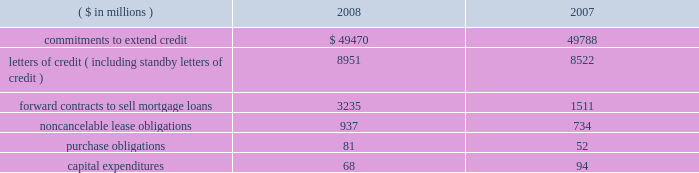Notes to consolidated financial statements fifth third bancorp 81 vii held by the trust vii bear a fixed rate of interest of 8.875% ( 8.875 % ) until may 15 , 2058 .
Thereafter , the notes pay a floating rate at three-month libor plus 500 bp .
The bancorp entered into an interest rate swap to convert $ 275 million of the fixed-rate debt into floating .
At december 31 , 2008 , the rate paid on the swap was 6.05% ( 6.05 % ) .
The jsn vii may be redeemed at the option of the bancorp on or after may 15 , 2013 , or in certain other limited circumstances , at a redemption price of 100% ( 100 % ) of the principal amount plus accrued but unpaid interest .
All redemptions are subject to certain conditions and generally require approval by the federal reserve board .
Subsidiary long-term borrowings the senior fixed-rate bank notes due from 2009 to 2019 are the obligations of a subsidiary bank .
The maturities of the face value of the senior fixed-rate bank notes are as follows : $ 36 million in 2009 , $ 800 million in 2010 and $ 275 million in 2019 .
The bancorp entered into interest rate swaps to convert $ 1.1 billion of the fixed-rate debt into floating rates .
At december 31 , 2008 , the rates paid on these swaps were 2.19% ( 2.19 % ) on $ 800 million and 2.20% ( 2.20 % ) on $ 275 million .
In august 2008 , $ 500 million of senior fixed-rate bank notes issued in july of 2003 matured and were paid .
These long-term bank notes were issued to third-party investors at a fixed rate of 3.375% ( 3.375 % ) .
The senior floating-rate bank notes due in 2013 are the obligations of a subsidiary bank .
The notes pay a floating rate at three-month libor plus 11 bp .
The senior extendable notes consist of $ 797 million that currently pay interest at three-month libor plus 4 bp and $ 400 million that pay at the federal funds open rate plus 12 bp .
The subordinated fixed-rate bank notes due in 2015 are the obligations of a subsidiary bank .
The bancorp entered into interest rate swaps to convert the fixed-rate debt into floating rate .
At december 31 , 2008 , the weighted-average rate paid on the swaps was 3.29% ( 3.29 % ) .
The junior subordinated floating-rate bank notes due in 2032 and 2033 were assumed by a bancorp subsidiary as part of the acquisition of crown in november 2007 .
Two of the notes pay floating at three-month libor plus 310 and 325 bp .
The third note pays floating at six-month libor plus 370 bp .
The three-month libor plus 290 bp and the three-month libor plus 279 bp junior subordinated debentures due in 2033 and 2034 , respectively , were assumed by a subsidiary of the bancorp in connection with the acquisition of first national bank .
The obligations were issued to fnb statutory trusts i and ii , respectively .
The junior subordinated floating-rate bank notes due in 2035 were assumed by a bancorp subsidiary as part of the acquisition of first charter in may 2008 .
The obligations were issued to first charter capital trust i and ii , respectively .
The notes of first charter capital trust i and ii pay floating at three-month libor plus 169 bp and 142 bp , respectively .
The bancorp has fully and unconditionally guaranteed all obligations under the acquired trust preferred securities .
At december 31 , 2008 , fhlb advances have rates ranging from 0% ( 0 % ) to 8.34% ( 8.34 % ) , with interest payable monthly .
The advances are secured by certain residential mortgage loans and securities totaling $ 8.6 billion .
At december 31 , 2008 , $ 2.5 billion of fhlb advances are floating rate .
The bancorp has interest rate caps , with a notional of $ 1.5 billion , held against its fhlb advance borrowings .
The $ 3.6 billion in advances mature as follows : $ 1.5 billion in 2009 , $ 1 million in 2010 , $ 2 million in 2011 , $ 1 billion in 2012 and $ 1.1 billion in 2013 and thereafter .
Medium-term senior notes and subordinated bank notes with maturities ranging from one year to 30 years can be issued by two subsidiary banks , of which $ 3.8 billion was outstanding at december 31 , 2008 with $ 16.2 billion available for future issuance .
There were no other medium-term senior notes outstanding on either of the two subsidiary banks as of december 31 , 2008 .
15 .
Commitments , contingent liabilities and guarantees the bancorp , in the normal course of business , enters into financial instruments and various agreements to meet the financing needs of its customers .
The bancorp also enters into certain transactions and agreements to manage its interest rate and prepayment risks , provide funding , equipment and locations for its operations and invest in its communities .
These instruments and agreements involve , to varying degrees , elements of credit risk , counterparty risk and market risk in excess of the amounts recognized in the bancorp 2019s consolidated balance sheets .
Creditworthiness for all instruments and agreements is evaluated on a case-by-case basis in accordance with the bancorp 2019s credit policies .
The bancorp 2019s significant commitments , contingent liabilities and guarantees in excess of the amounts recognized in the consolidated balance sheets are summarized as follows : commitments the bancorp has certain commitments to make future payments under contracts .
A summary of significant commitments at december 31: .
Commitments to extend credit are agreements to lend , typically having fixed expiration dates or other termination clauses that may require payment of a fee .
Since many of the commitments to extend credit may expire without being drawn upon , the total commitment amounts do not necessarily represent future cash flow requirements .
The bancorp is exposed to credit risk in the event of nonperformance for the amount of the contract .
Fixed-rate commitments are also subject to market risk resulting from fluctuations in interest rates and the bancorp 2019s exposure is limited to the replacement value of those commitments .
As of december 31 , 2008 and 2007 , the bancorp had a reserve for unfunded commitments totaling $ 195 million and $ 95 million , respectively , included in other liabilities in the consolidated balance sheets .
Standby and commercial letters of credit are conditional commitments issued to guarantee the performance of a customer to a third party .
At december 31 , 2008 , approximately $ 3.3 billion of letters of credit expire within one year ( including $ 57 million issued on behalf of commercial customers to facilitate trade payments in dollars and foreign currencies ) , $ 5.3 billion expire between one to five years and $ 0.4 billion expire thereafter .
Standby letters of credit are considered guarantees in accordance with fasb interpretation no .
45 , 201cguarantor 2019s accounting and disclosure requirements for guarantees , including indirect guarantees of indebtedness of others 201d ( fin 45 ) .
At december 31 , 2008 , the reserve related to these standby letters of credit was $ 3 million .
Approximately 66% ( 66 % ) and 70% ( 70 % ) of the total standby letters of credit were secured as of december 31 , 2008 and 2007 , respectively .
In the event of nonperformance by the customers , the bancorp has rights to the underlying collateral , which can include commercial real estate , physical plant and property , inventory , receivables , cash and marketable securities .
The bancorp monitors the credit risk associated with the standby letters of credit using the same dual risk rating system utilized for .
What is the percentage change in capital expenditures from 2007 to 2008? 
Computations: ((68 - 94) / 94)
Answer: -0.2766. 